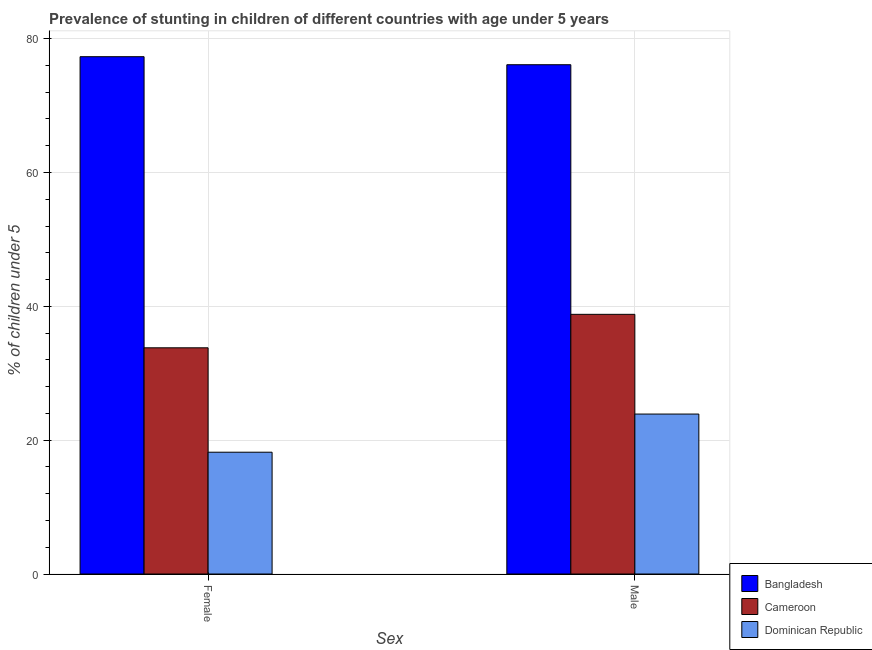How many different coloured bars are there?
Your response must be concise. 3. Are the number of bars on each tick of the X-axis equal?
Offer a terse response. Yes. What is the percentage of stunted female children in Bangladesh?
Provide a short and direct response. 77.3. Across all countries, what is the maximum percentage of stunted male children?
Ensure brevity in your answer.  76.1. Across all countries, what is the minimum percentage of stunted male children?
Offer a terse response. 23.9. In which country was the percentage of stunted male children minimum?
Offer a terse response. Dominican Republic. What is the total percentage of stunted male children in the graph?
Provide a short and direct response. 138.8. What is the difference between the percentage of stunted male children in Bangladesh and that in Dominican Republic?
Your answer should be very brief. 52.2. What is the difference between the percentage of stunted male children in Cameroon and the percentage of stunted female children in Bangladesh?
Ensure brevity in your answer.  -38.5. What is the average percentage of stunted male children per country?
Ensure brevity in your answer.  46.27. What is the difference between the percentage of stunted male children and percentage of stunted female children in Dominican Republic?
Ensure brevity in your answer.  5.7. In how many countries, is the percentage of stunted male children greater than 44 %?
Keep it short and to the point. 1. What is the ratio of the percentage of stunted male children in Cameroon to that in Bangladesh?
Make the answer very short. 0.51. What does the 2nd bar from the right in Female represents?
Offer a very short reply. Cameroon. Does the graph contain any zero values?
Keep it short and to the point. No. Where does the legend appear in the graph?
Your answer should be very brief. Bottom right. What is the title of the graph?
Make the answer very short. Prevalence of stunting in children of different countries with age under 5 years. What is the label or title of the X-axis?
Your answer should be very brief. Sex. What is the label or title of the Y-axis?
Make the answer very short.  % of children under 5. What is the  % of children under 5 in Bangladesh in Female?
Your answer should be very brief. 77.3. What is the  % of children under 5 of Cameroon in Female?
Provide a succinct answer. 33.8. What is the  % of children under 5 of Dominican Republic in Female?
Make the answer very short. 18.2. What is the  % of children under 5 in Bangladesh in Male?
Provide a succinct answer. 76.1. What is the  % of children under 5 in Cameroon in Male?
Keep it short and to the point. 38.8. What is the  % of children under 5 of Dominican Republic in Male?
Offer a terse response. 23.9. Across all Sex, what is the maximum  % of children under 5 of Bangladesh?
Ensure brevity in your answer.  77.3. Across all Sex, what is the maximum  % of children under 5 in Cameroon?
Provide a succinct answer. 38.8. Across all Sex, what is the maximum  % of children under 5 of Dominican Republic?
Provide a succinct answer. 23.9. Across all Sex, what is the minimum  % of children under 5 in Bangladesh?
Your answer should be compact. 76.1. Across all Sex, what is the minimum  % of children under 5 of Cameroon?
Make the answer very short. 33.8. Across all Sex, what is the minimum  % of children under 5 of Dominican Republic?
Give a very brief answer. 18.2. What is the total  % of children under 5 of Bangladesh in the graph?
Offer a very short reply. 153.4. What is the total  % of children under 5 of Cameroon in the graph?
Ensure brevity in your answer.  72.6. What is the total  % of children under 5 of Dominican Republic in the graph?
Ensure brevity in your answer.  42.1. What is the difference between the  % of children under 5 of Bangladesh in Female and the  % of children under 5 of Cameroon in Male?
Make the answer very short. 38.5. What is the difference between the  % of children under 5 of Bangladesh in Female and the  % of children under 5 of Dominican Republic in Male?
Your response must be concise. 53.4. What is the difference between the  % of children under 5 of Cameroon in Female and the  % of children under 5 of Dominican Republic in Male?
Offer a terse response. 9.9. What is the average  % of children under 5 of Bangladesh per Sex?
Provide a short and direct response. 76.7. What is the average  % of children under 5 in Cameroon per Sex?
Your response must be concise. 36.3. What is the average  % of children under 5 in Dominican Republic per Sex?
Your answer should be very brief. 21.05. What is the difference between the  % of children under 5 in Bangladesh and  % of children under 5 in Cameroon in Female?
Give a very brief answer. 43.5. What is the difference between the  % of children under 5 of Bangladesh and  % of children under 5 of Dominican Republic in Female?
Offer a very short reply. 59.1. What is the difference between the  % of children under 5 of Bangladesh and  % of children under 5 of Cameroon in Male?
Your answer should be compact. 37.3. What is the difference between the  % of children under 5 in Bangladesh and  % of children under 5 in Dominican Republic in Male?
Provide a short and direct response. 52.2. What is the ratio of the  % of children under 5 in Bangladesh in Female to that in Male?
Give a very brief answer. 1.02. What is the ratio of the  % of children under 5 in Cameroon in Female to that in Male?
Provide a succinct answer. 0.87. What is the ratio of the  % of children under 5 of Dominican Republic in Female to that in Male?
Make the answer very short. 0.76. What is the difference between the highest and the second highest  % of children under 5 of Bangladesh?
Offer a terse response. 1.2. What is the difference between the highest and the second highest  % of children under 5 in Cameroon?
Offer a very short reply. 5. 